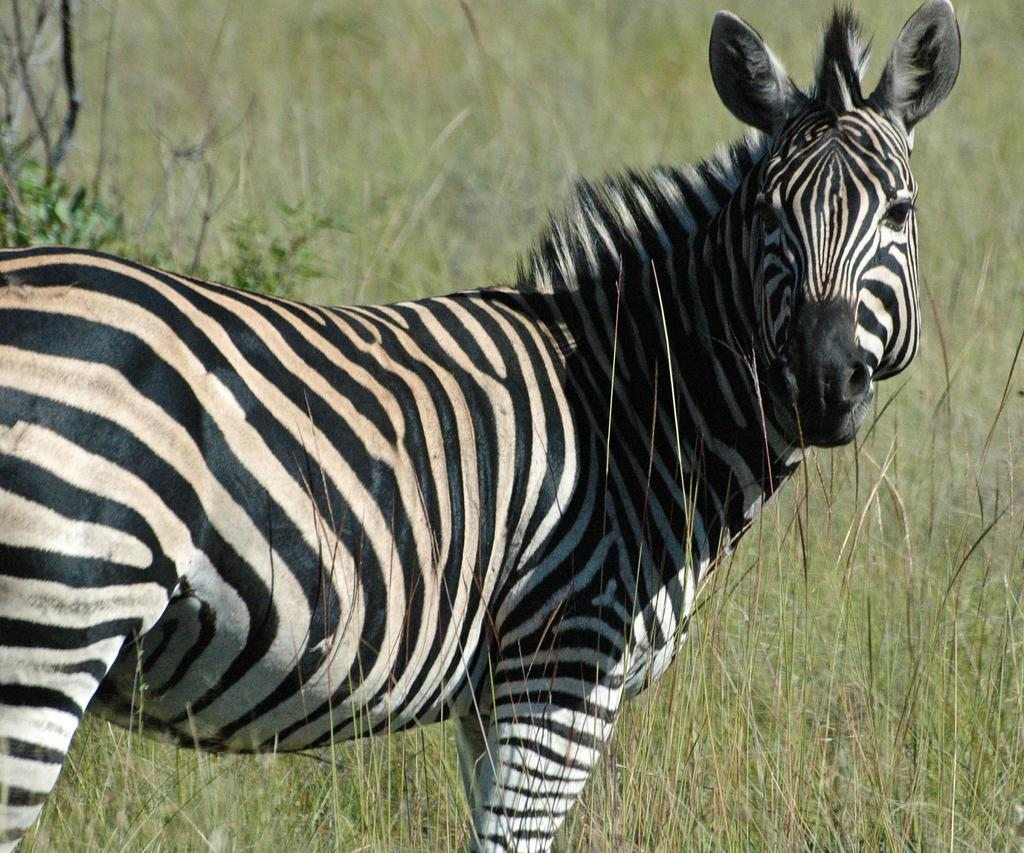What type of animal is in the image? There is a zebra in the image. What is the zebra standing on in the image? The zebra is standing on the surface of the grass. How does the zebra sort the grass in the image? The zebra does not sort the grass in the image; it is simply standing on the surface of the grass. 